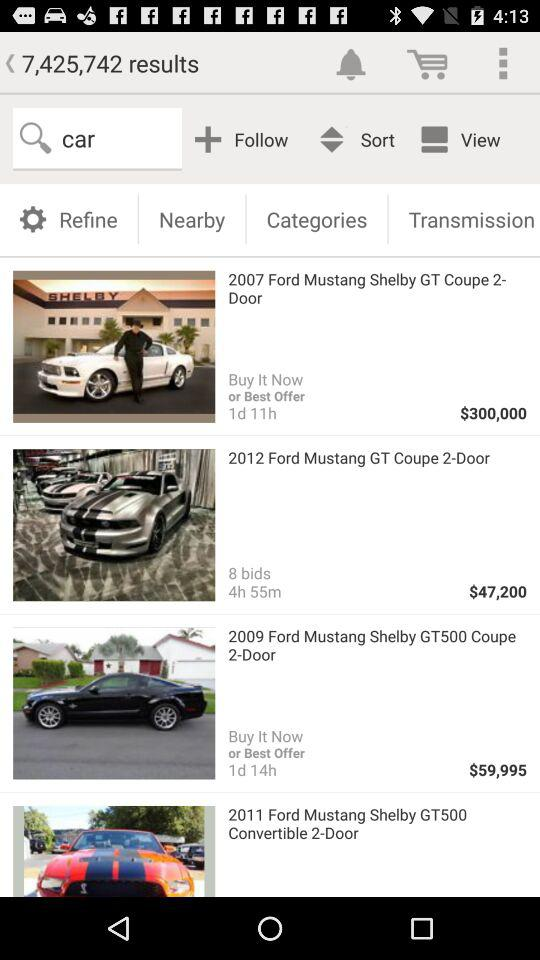How many results are there? There are 7,425,742 results. 